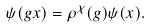Convert formula to latex. <formula><loc_0><loc_0><loc_500><loc_500>\psi ( g x ) = \rho ^ { \chi } ( g ) \psi ( x ) .</formula> 